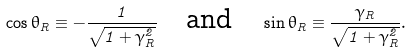<formula> <loc_0><loc_0><loc_500><loc_500>\cos \theta _ { R } \equiv - \frac { 1 } { \sqrt { 1 + \gamma _ { R } ^ { 2 } } } \quad \text {and} \quad \sin \theta _ { R } \equiv \frac { \gamma _ { R } } { \sqrt { 1 + \gamma _ { R } ^ { 2 } } } .</formula> 